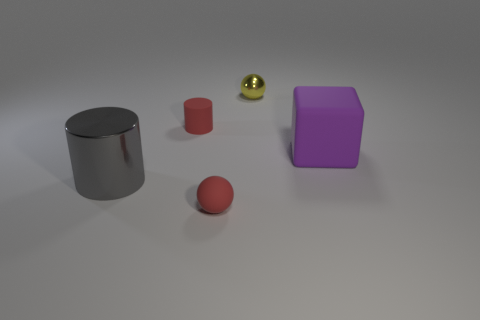How many things have the same material as the small red cylinder?
Keep it short and to the point. 2. How many things are either gray metal things or red things?
Provide a short and direct response. 3. Are there any small yellow metal objects behind the metal object that is behind the big gray metal object?
Offer a terse response. No. Are there more tiny yellow objects in front of the big gray object than small yellow balls behind the tiny metal sphere?
Offer a terse response. No. There is a tiny object that is the same color as the rubber sphere; what material is it?
Make the answer very short. Rubber. How many tiny metal balls have the same color as the small rubber cylinder?
Provide a succinct answer. 0. Do the tiny sphere on the left side of the metal ball and the small thing that is to the left of the red rubber ball have the same color?
Keep it short and to the point. Yes. There is a tiny red sphere; are there any small red objects behind it?
Keep it short and to the point. Yes. What is the material of the red cylinder?
Your answer should be compact. Rubber. The tiny object in front of the large gray object has what shape?
Give a very brief answer. Sphere. 